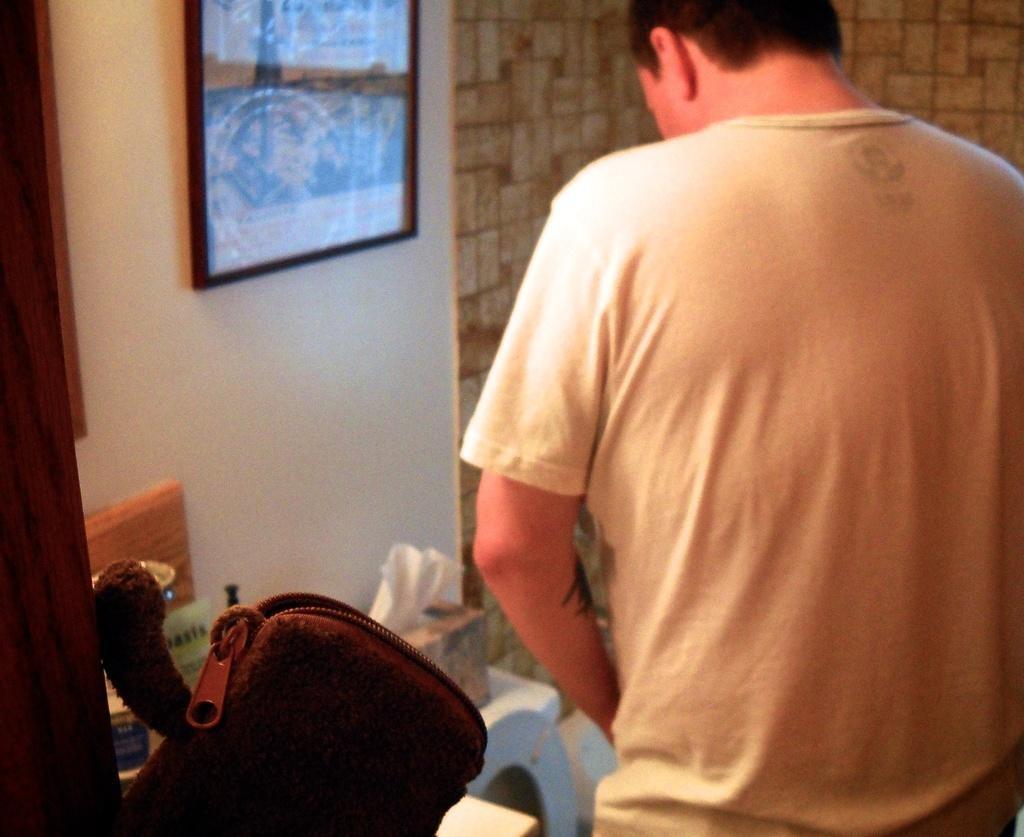What is the main subject of the image? There is a person in the image. What is the person doing in the image? The person is turning around. Where is the person standing in the image? The person is standing in front of a commode. What items can be seen near the person in the image? There are tissues, a bag, and a photo frame visible in the image. What is the person's tendency to wear a veil in the image? There is no veil present in the image, so it is not possible to determine the person's tendency to wear one. How many cents are visible in the image? There are no cents present in the image. 